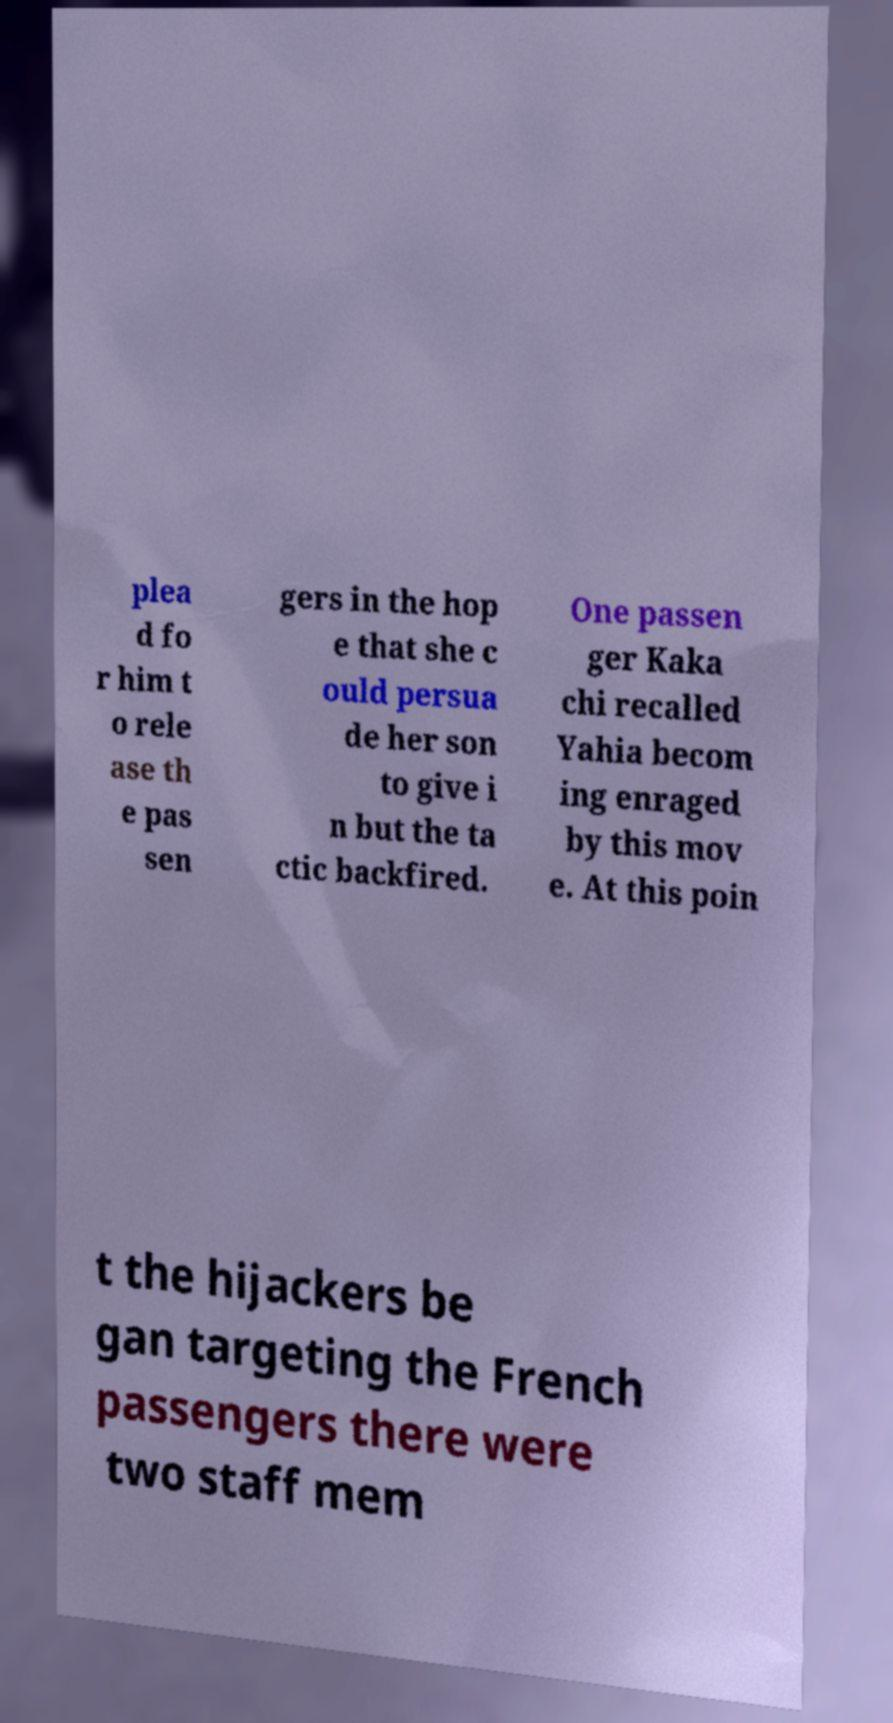Can you accurately transcribe the text from the provided image for me? plea d fo r him t o rele ase th e pas sen gers in the hop e that she c ould persua de her son to give i n but the ta ctic backfired. One passen ger Kaka chi recalled Yahia becom ing enraged by this mov e. At this poin t the hijackers be gan targeting the French passengers there were two staff mem 